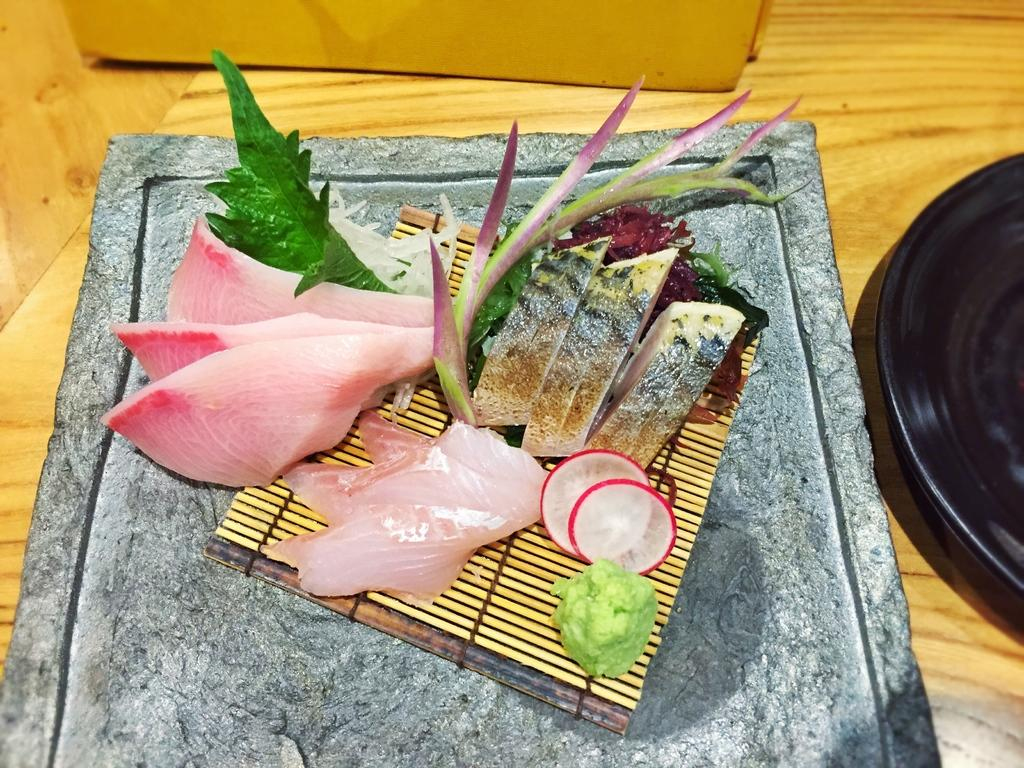What types of items can be seen in the image? There are food items in the image. Where are the food items located? The food items are placed on a surface. What direction is the heart pointing in the image? There is no heart present in the image, so it is not possible to determine the direction it might be pointing. 